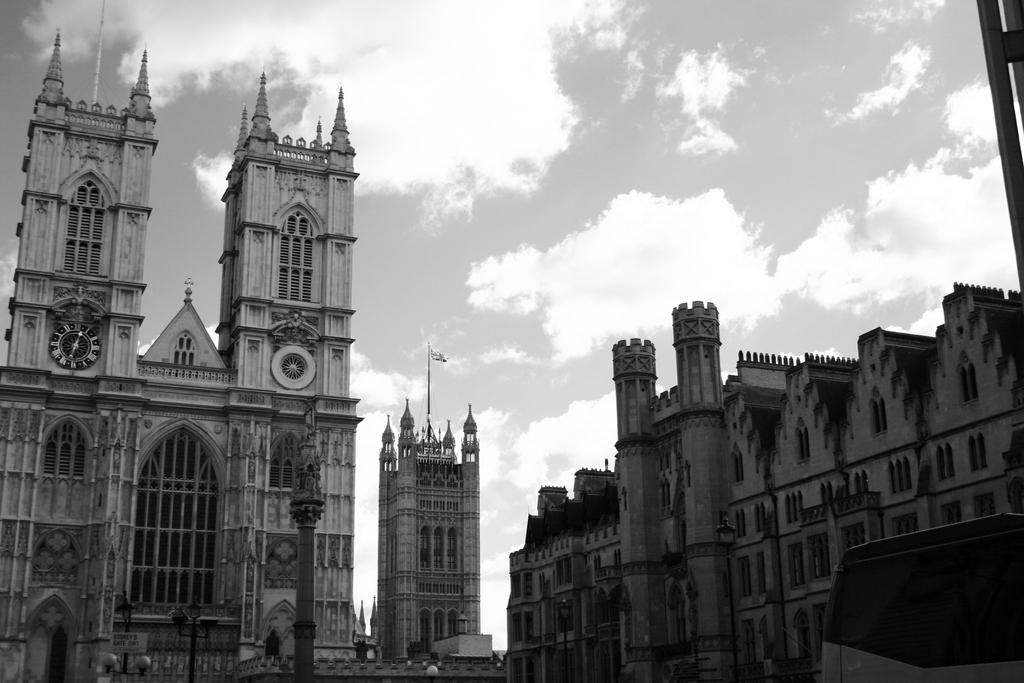What type of structures can be seen in the image? There are buildings in the image. Can you describe a specific feature of one of the buildings? Yes, there is a clock on the pillar of a building. Where is the clock located in relation to the image? The clock is on the left side of the image. What is the weather like in the image? The sky is cloudy in the image. What type of knot is being tied by the person in the image? There is no person present in the image, and therefore no one is tying a knot. What type of tank can be seen in the image? There is no tank present in the image. 